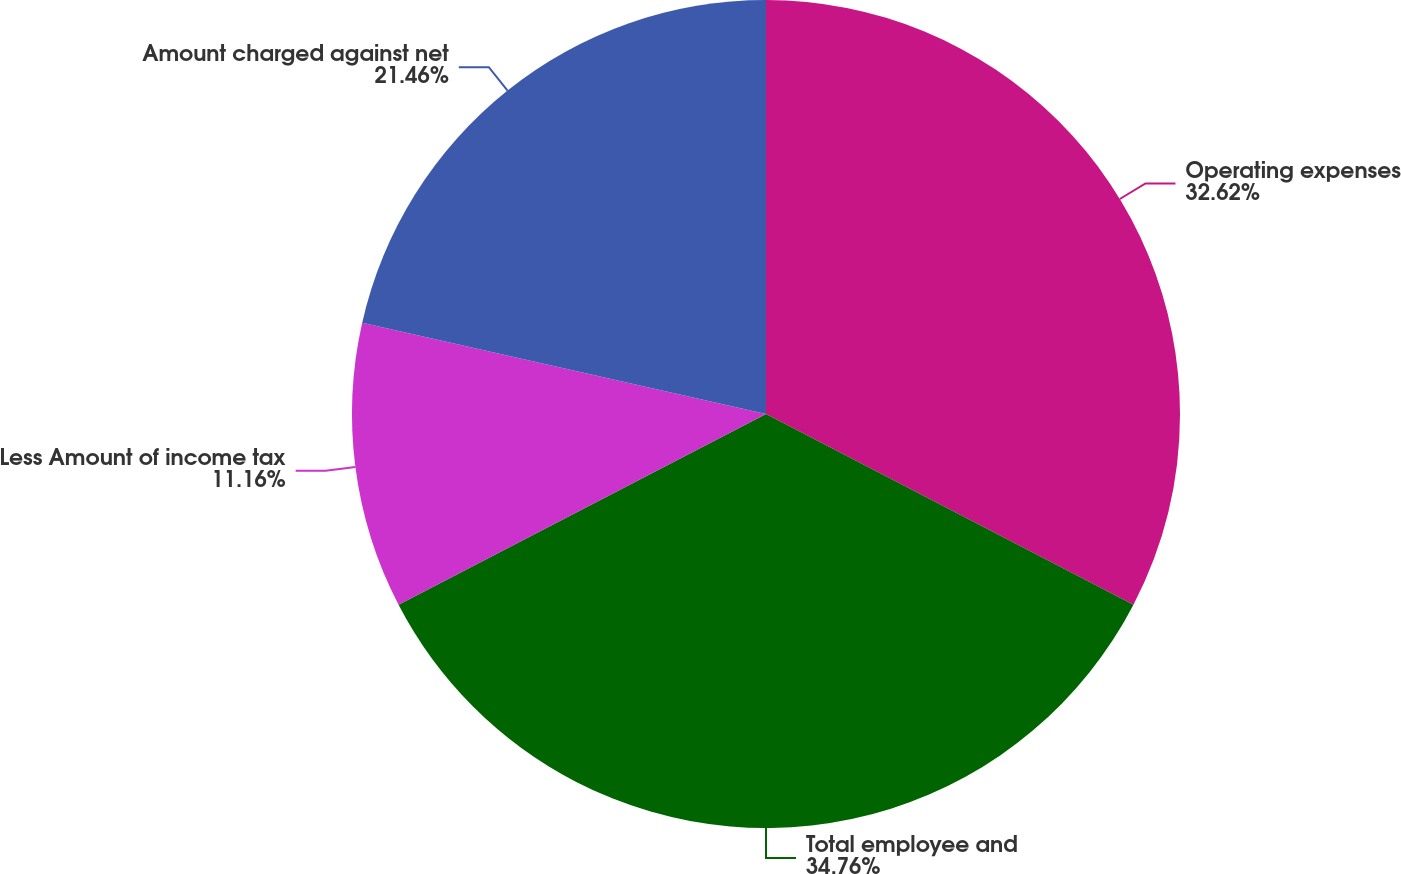Convert chart to OTSL. <chart><loc_0><loc_0><loc_500><loc_500><pie_chart><fcel>Operating expenses<fcel>Total employee and<fcel>Less Amount of income tax<fcel>Amount charged against net<nl><fcel>32.62%<fcel>34.76%<fcel>11.16%<fcel>21.46%<nl></chart> 